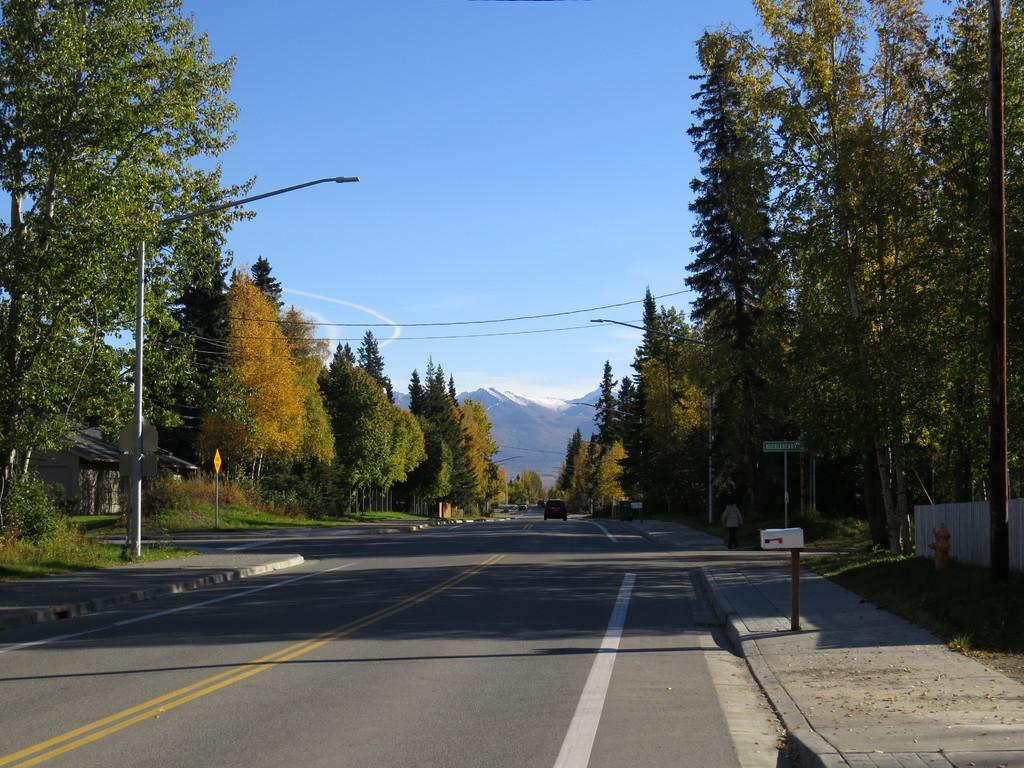What is the main feature of the image? There is a road in the image. What structures can be seen alongside the road? Street poles and sign boards are present in the image. What type of lighting is visible in the image? Street lights are visible in the image. Can you describe the person in the image? There is a person on the footpath in the image. What mode of transportation is present in the image? A motor vehicle is present in the image. What safety feature can be seen in the image? A hydrant is visible in the image. What is visible in the background of the image? The sky, clouds, and mountains are visible in the image. What type of marble is used for the selection of health products in the image? There is no marble or health products present in the image. 